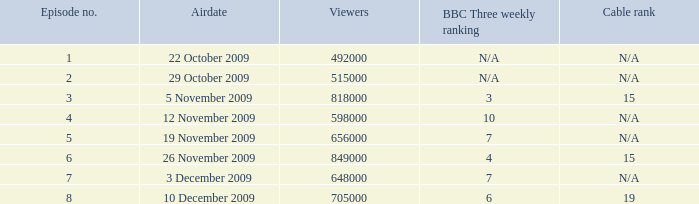What is the position of bbc three in the weekly cable ranking with an n/a status? N/A, N/A. 